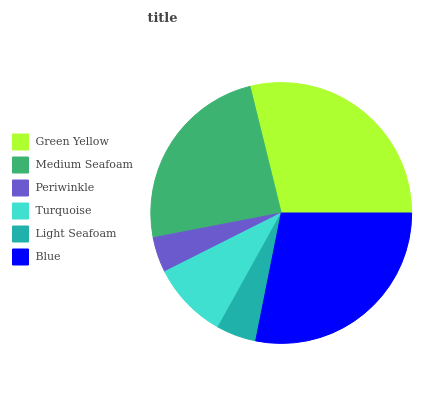Is Periwinkle the minimum?
Answer yes or no. Yes. Is Green Yellow the maximum?
Answer yes or no. Yes. Is Medium Seafoam the minimum?
Answer yes or no. No. Is Medium Seafoam the maximum?
Answer yes or no. No. Is Green Yellow greater than Medium Seafoam?
Answer yes or no. Yes. Is Medium Seafoam less than Green Yellow?
Answer yes or no. Yes. Is Medium Seafoam greater than Green Yellow?
Answer yes or no. No. Is Green Yellow less than Medium Seafoam?
Answer yes or no. No. Is Medium Seafoam the high median?
Answer yes or no. Yes. Is Turquoise the low median?
Answer yes or no. Yes. Is Light Seafoam the high median?
Answer yes or no. No. Is Medium Seafoam the low median?
Answer yes or no. No. 